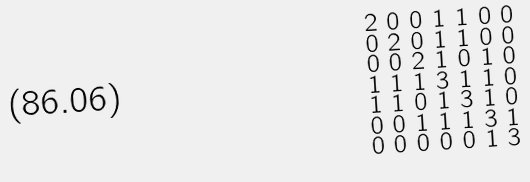Convert formula to latex. <formula><loc_0><loc_0><loc_500><loc_500>\begin{smallmatrix} 2 & 0 & 0 & 1 & 1 & 0 & 0 \\ 0 & 2 & 0 & 1 & 1 & 0 & 0 \\ 0 & 0 & 2 & 1 & 0 & 1 & 0 \\ 1 & 1 & 1 & 3 & 1 & 1 & 0 \\ 1 & 1 & 0 & 1 & 3 & 1 & 0 \\ 0 & 0 & 1 & 1 & 1 & 3 & 1 \\ 0 & 0 & 0 & 0 & 0 & 1 & 3 \end{smallmatrix}</formula> 